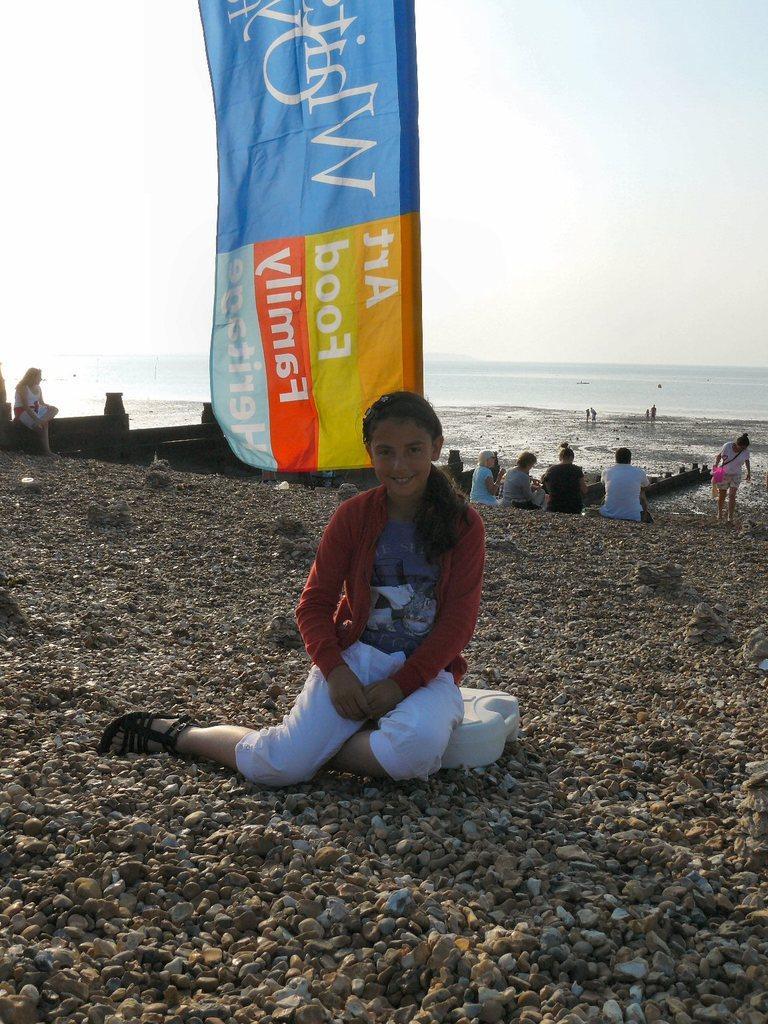How would you summarize this image in a sentence or two? In this image I can see people among them some are sitting and some are standing on the ground. Here I can see a banner which has something written on it. In the background I can see the water and the sky. 